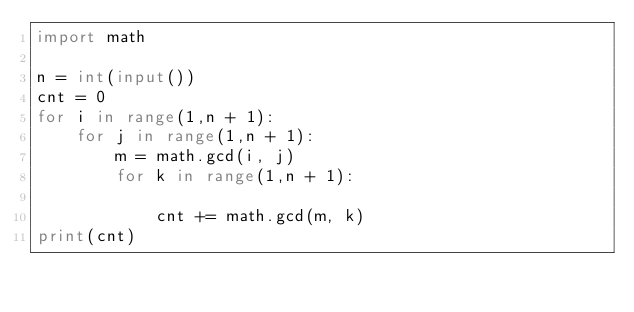<code> <loc_0><loc_0><loc_500><loc_500><_Python_>import math

n = int(input())
cnt = 0
for i in range(1,n + 1):
    for j in range(1,n + 1):
        m = math.gcd(i, j)
        for k in range(1,n + 1):
            
            cnt += math.gcd(m, k)
print(cnt)</code> 